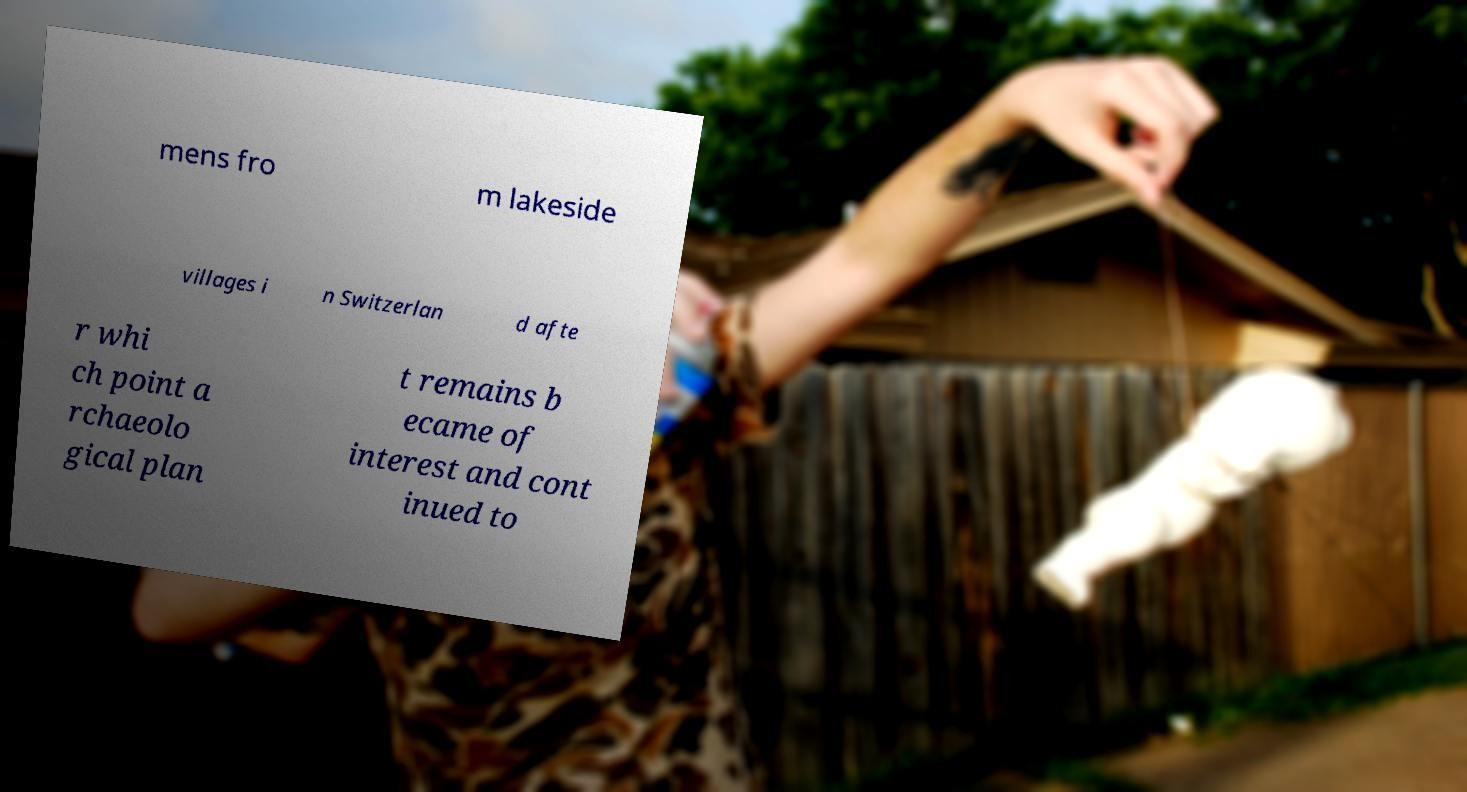Could you extract and type out the text from this image? mens fro m lakeside villages i n Switzerlan d afte r whi ch point a rchaeolo gical plan t remains b ecame of interest and cont inued to 